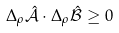<formula> <loc_0><loc_0><loc_500><loc_500>\Delta _ { \rho } \hat { \mathcal { A } } \cdot \Delta _ { \rho } \hat { \mathcal { B } } \geq 0</formula> 